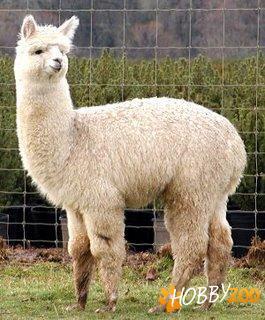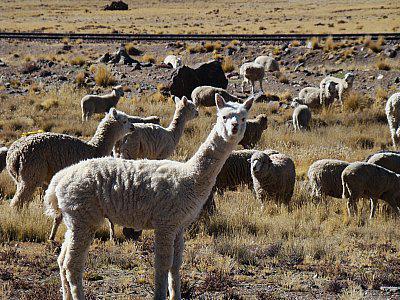The first image is the image on the left, the second image is the image on the right. For the images displayed, is the sentence "One image shows at least ten llamas standing in place with their heads upright and angled rightward." factually correct? Answer yes or no. No. 